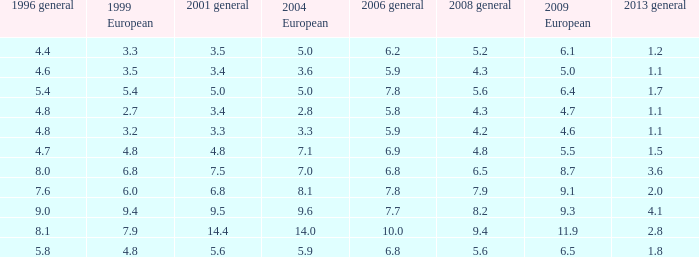What was the value for 2004 European with less than 7.5 in general 2001, less than 6.4 in 2009 European, and less than 1.5 in general 2013 with 4.3 in 2008 general? 3.6, 2.8. 